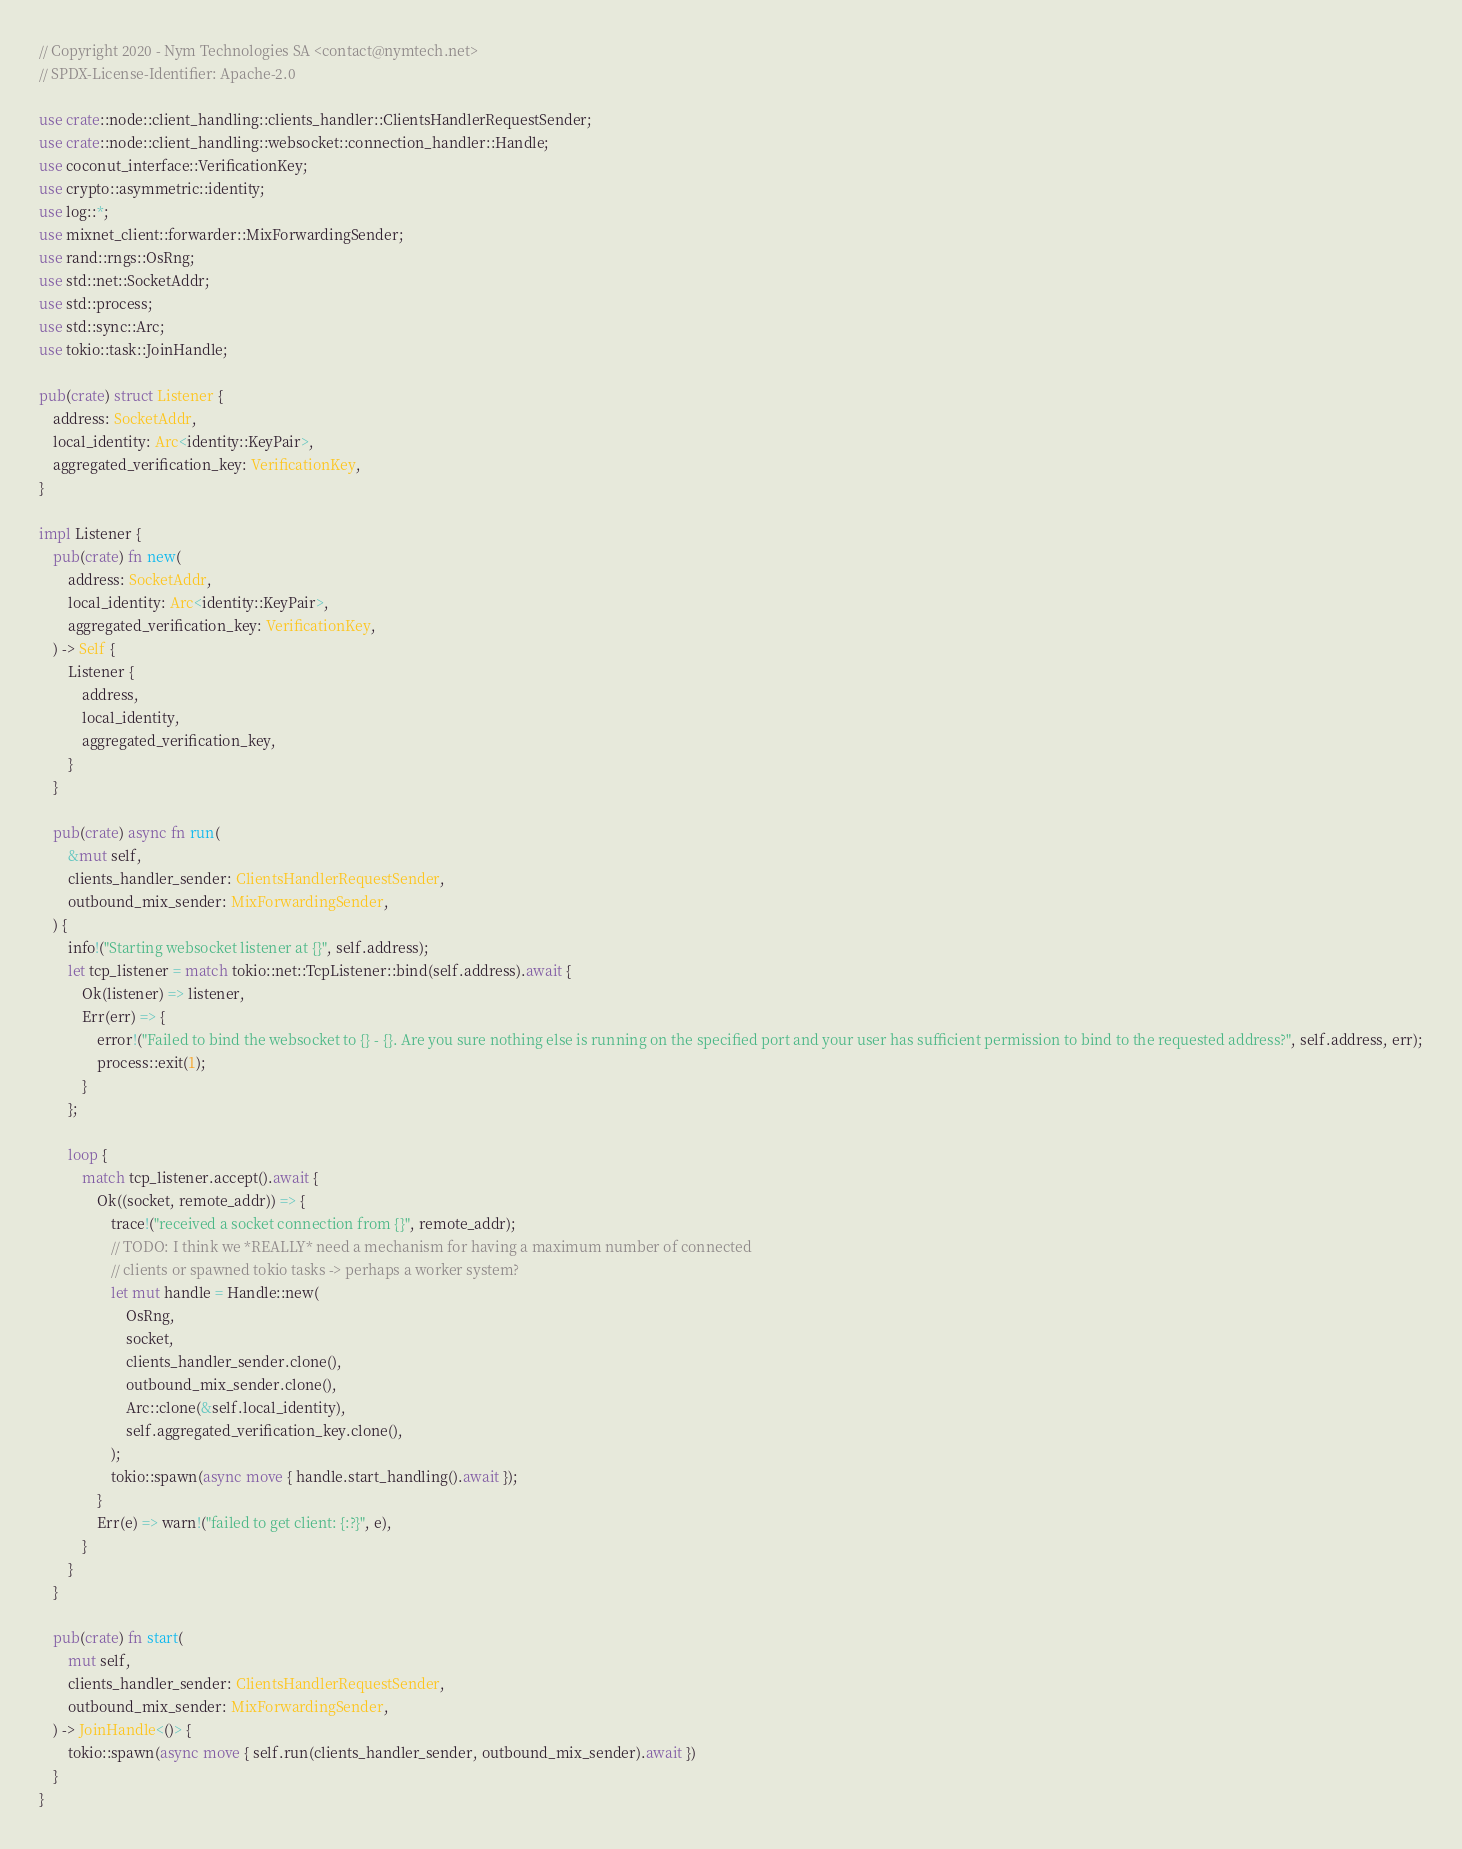<code> <loc_0><loc_0><loc_500><loc_500><_Rust_>// Copyright 2020 - Nym Technologies SA <contact@nymtech.net>
// SPDX-License-Identifier: Apache-2.0

use crate::node::client_handling::clients_handler::ClientsHandlerRequestSender;
use crate::node::client_handling::websocket::connection_handler::Handle;
use coconut_interface::VerificationKey;
use crypto::asymmetric::identity;
use log::*;
use mixnet_client::forwarder::MixForwardingSender;
use rand::rngs::OsRng;
use std::net::SocketAddr;
use std::process;
use std::sync::Arc;
use tokio::task::JoinHandle;

pub(crate) struct Listener {
    address: SocketAddr,
    local_identity: Arc<identity::KeyPair>,
    aggregated_verification_key: VerificationKey,
}

impl Listener {
    pub(crate) fn new(
        address: SocketAddr,
        local_identity: Arc<identity::KeyPair>,
        aggregated_verification_key: VerificationKey,
    ) -> Self {
        Listener {
            address,
            local_identity,
            aggregated_verification_key,
        }
    }

    pub(crate) async fn run(
        &mut self,
        clients_handler_sender: ClientsHandlerRequestSender,
        outbound_mix_sender: MixForwardingSender,
    ) {
        info!("Starting websocket listener at {}", self.address);
        let tcp_listener = match tokio::net::TcpListener::bind(self.address).await {
            Ok(listener) => listener,
            Err(err) => {
                error!("Failed to bind the websocket to {} - {}. Are you sure nothing else is running on the specified port and your user has sufficient permission to bind to the requested address?", self.address, err);
                process::exit(1);
            }
        };

        loop {
            match tcp_listener.accept().await {
                Ok((socket, remote_addr)) => {
                    trace!("received a socket connection from {}", remote_addr);
                    // TODO: I think we *REALLY* need a mechanism for having a maximum number of connected
                    // clients or spawned tokio tasks -> perhaps a worker system?
                    let mut handle = Handle::new(
                        OsRng,
                        socket,
                        clients_handler_sender.clone(),
                        outbound_mix_sender.clone(),
                        Arc::clone(&self.local_identity),
                        self.aggregated_verification_key.clone(),
                    );
                    tokio::spawn(async move { handle.start_handling().await });
                }
                Err(e) => warn!("failed to get client: {:?}", e),
            }
        }
    }

    pub(crate) fn start(
        mut self,
        clients_handler_sender: ClientsHandlerRequestSender,
        outbound_mix_sender: MixForwardingSender,
    ) -> JoinHandle<()> {
        tokio::spawn(async move { self.run(clients_handler_sender, outbound_mix_sender).await })
    }
}
</code> 